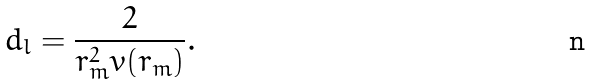Convert formula to latex. <formula><loc_0><loc_0><loc_500><loc_500>d _ { l } = \frac { 2 } { r _ { m } ^ { 2 } v ( r _ { m } ) } .</formula> 